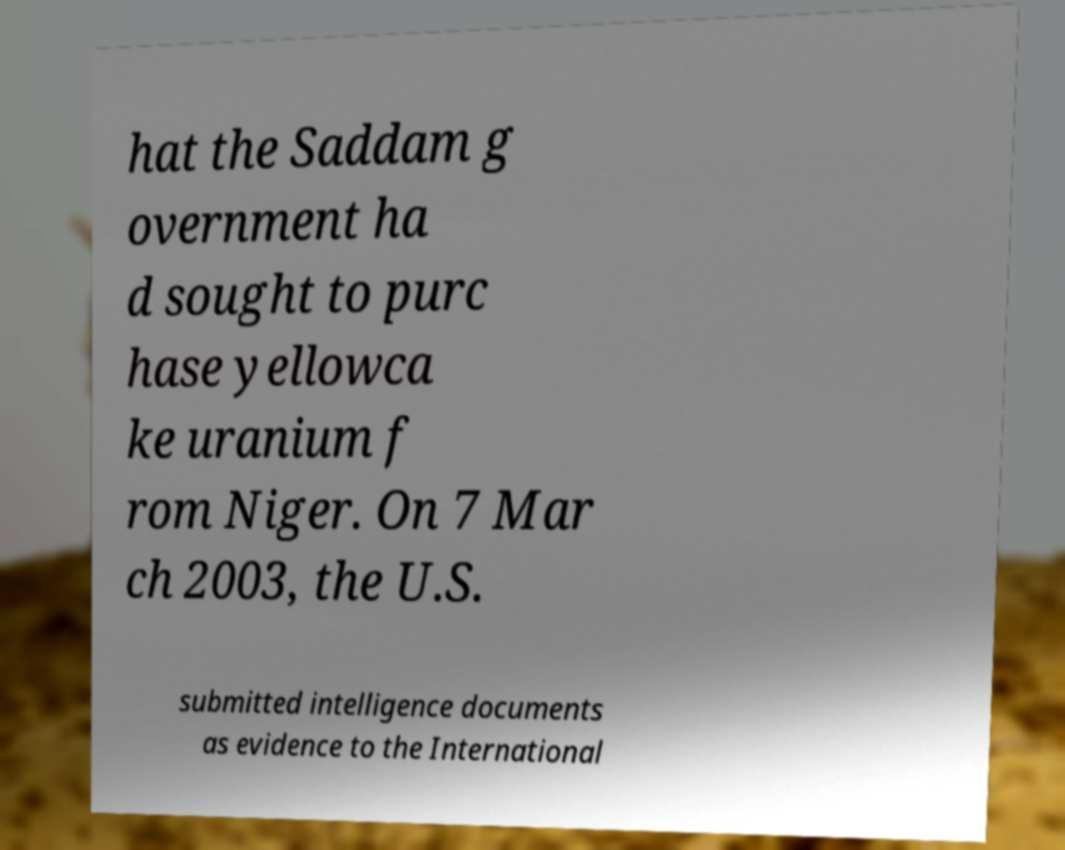Please read and relay the text visible in this image. What does it say? hat the Saddam g overnment ha d sought to purc hase yellowca ke uranium f rom Niger. On 7 Mar ch 2003, the U.S. submitted intelligence documents as evidence to the International 